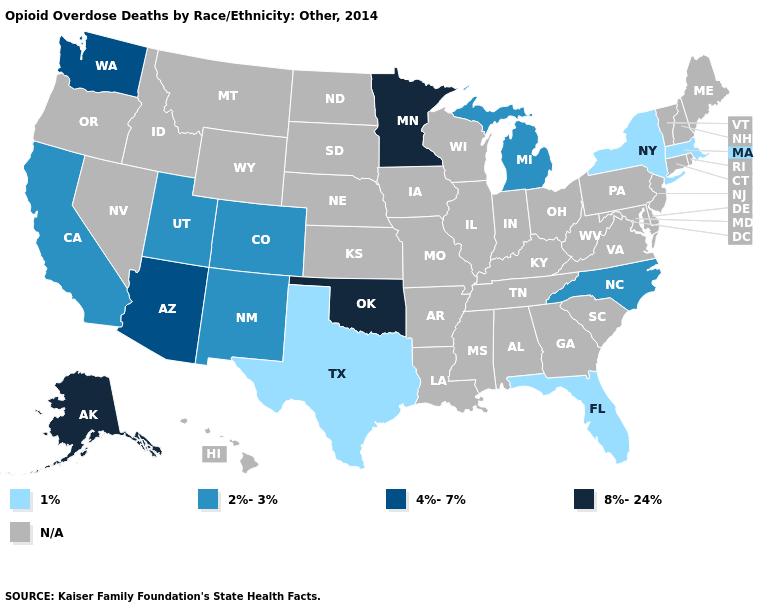What is the lowest value in states that border South Carolina?
Keep it brief. 2%-3%. Among the states that border Pennsylvania , which have the highest value?
Write a very short answer. New York. How many symbols are there in the legend?
Write a very short answer. 5. Does Oklahoma have the highest value in the South?
Be succinct. Yes. Which states have the lowest value in the USA?
Be succinct. Florida, Massachusetts, New York, Texas. What is the value of Michigan?
Write a very short answer. 2%-3%. Name the states that have a value in the range 4%-7%?
Answer briefly. Arizona, Washington. Name the states that have a value in the range 4%-7%?
Be succinct. Arizona, Washington. What is the highest value in the USA?
Concise answer only. 8%-24%. Does the first symbol in the legend represent the smallest category?
Answer briefly. Yes. What is the value of Wyoming?
Give a very brief answer. N/A. Which states hav the highest value in the Northeast?
Answer briefly. Massachusetts, New York. Is the legend a continuous bar?
Quick response, please. No. 